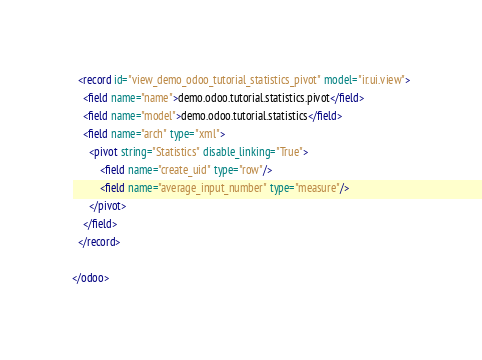<code> <loc_0><loc_0><loc_500><loc_500><_XML_>
  <record id="view_demo_odoo_tutorial_statistics_pivot" model="ir.ui.view">
    <field name="name">demo.odoo.tutorial.statistics.pivot</field>
    <field name="model">demo.odoo.tutorial.statistics</field>
    <field name="arch" type="xml">
      <pivot string="Statistics" disable_linking="True">
          <field name="create_uid" type="row"/>
          <field name="average_input_number" type="measure"/>
      </pivot>
    </field>
  </record>

</odoo></code> 